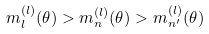Convert formula to latex. <formula><loc_0><loc_0><loc_500><loc_500>m _ { l } ^ { ( l ) } ( \theta ) > m _ { n } ^ { ( l ) } ( \theta ) > m _ { n ^ { \prime } } ^ { ( l ) } ( \theta )</formula> 